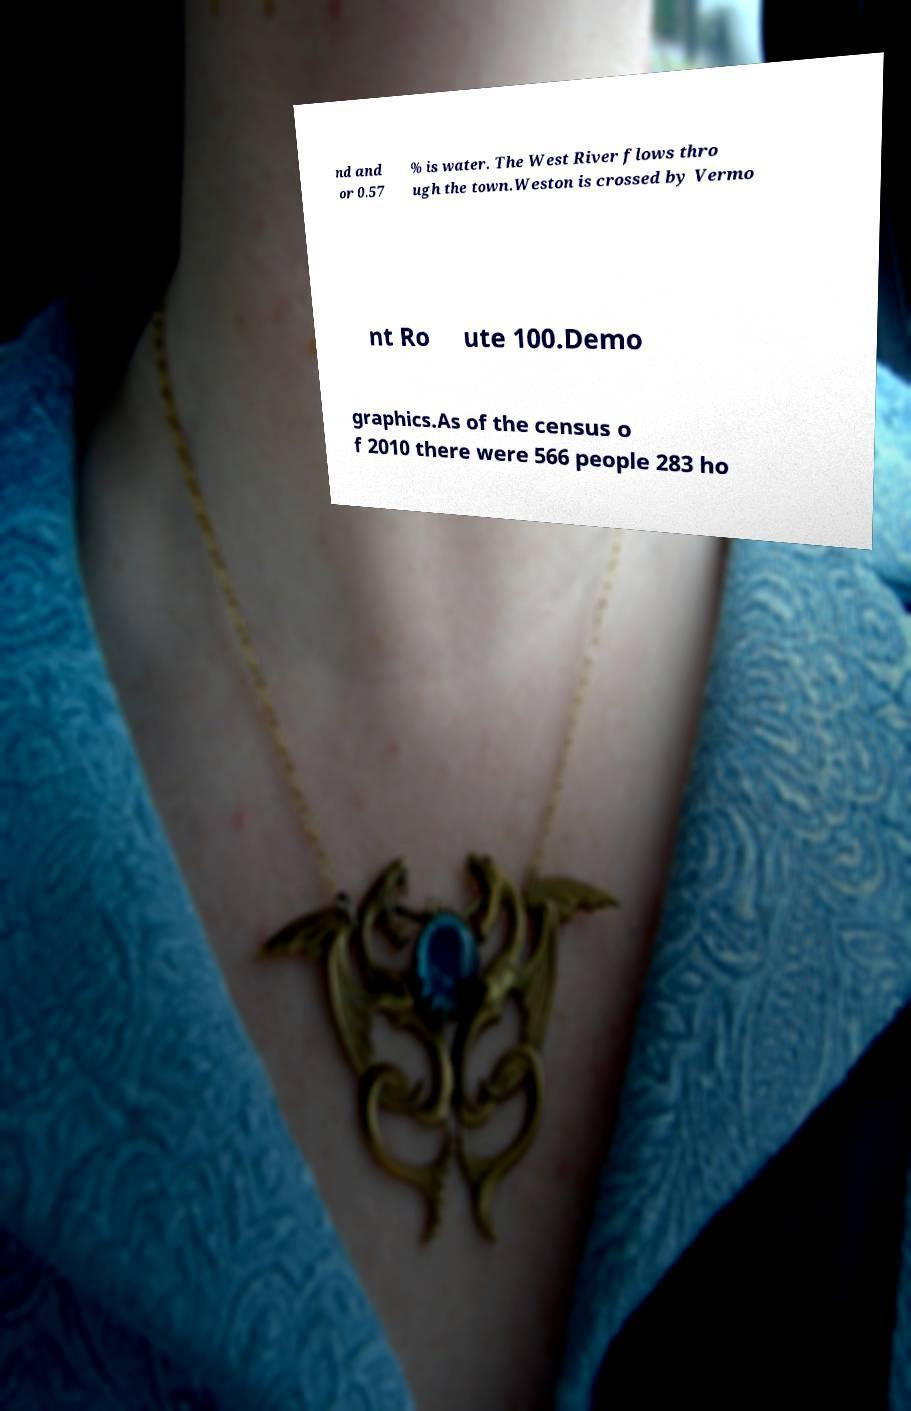What messages or text are displayed in this image? I need them in a readable, typed format. nd and or 0.57 % is water. The West River flows thro ugh the town.Weston is crossed by Vermo nt Ro ute 100.Demo graphics.As of the census o f 2010 there were 566 people 283 ho 